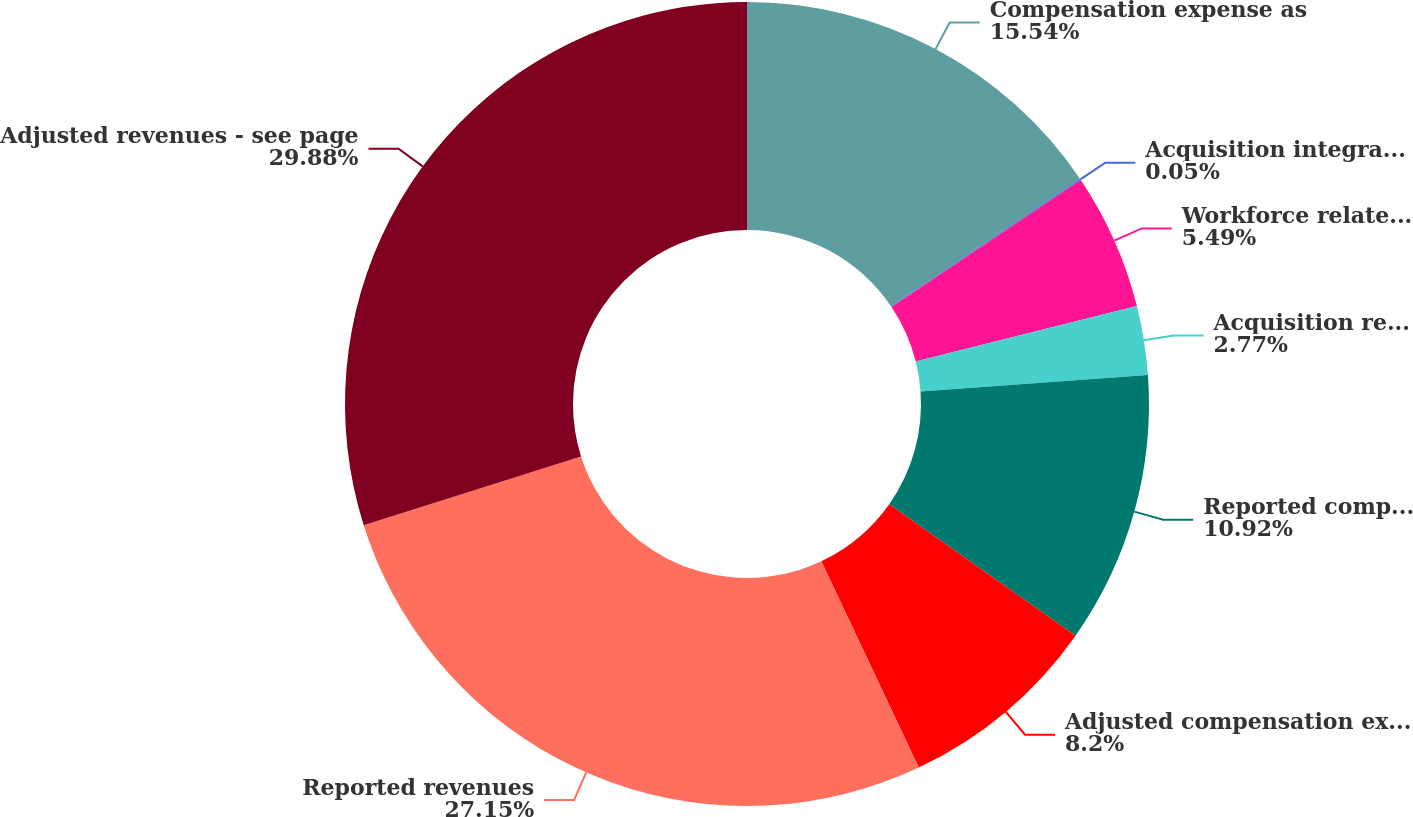Convert chart. <chart><loc_0><loc_0><loc_500><loc_500><pie_chart><fcel>Compensation expense as<fcel>Acquisition integration<fcel>Workforce related charges<fcel>Acquisition related<fcel>Reported compensation expense<fcel>Adjusted compensation expense<fcel>Reported revenues<fcel>Adjusted revenues - see page<nl><fcel>15.54%<fcel>0.05%<fcel>5.49%<fcel>2.77%<fcel>10.92%<fcel>8.2%<fcel>27.15%<fcel>29.87%<nl></chart> 